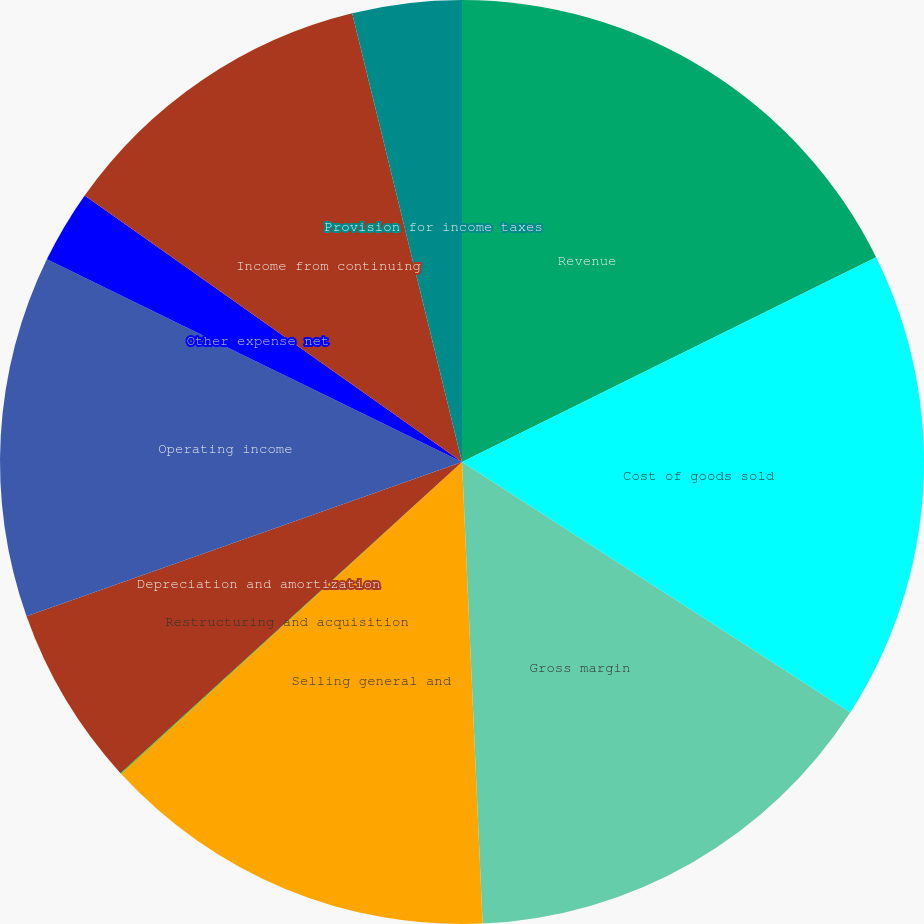<chart> <loc_0><loc_0><loc_500><loc_500><pie_chart><fcel>Revenue<fcel>Cost of goods sold<fcel>Gross margin<fcel>Selling general and<fcel>Restructuring and acquisition<fcel>Depreciation and amortization<fcel>Operating income<fcel>Other expense net<fcel>Income from continuing<fcel>Provision for income taxes<nl><fcel>17.69%<fcel>16.43%<fcel>15.17%<fcel>13.91%<fcel>0.04%<fcel>6.34%<fcel>12.65%<fcel>2.56%<fcel>11.39%<fcel>3.82%<nl></chart> 